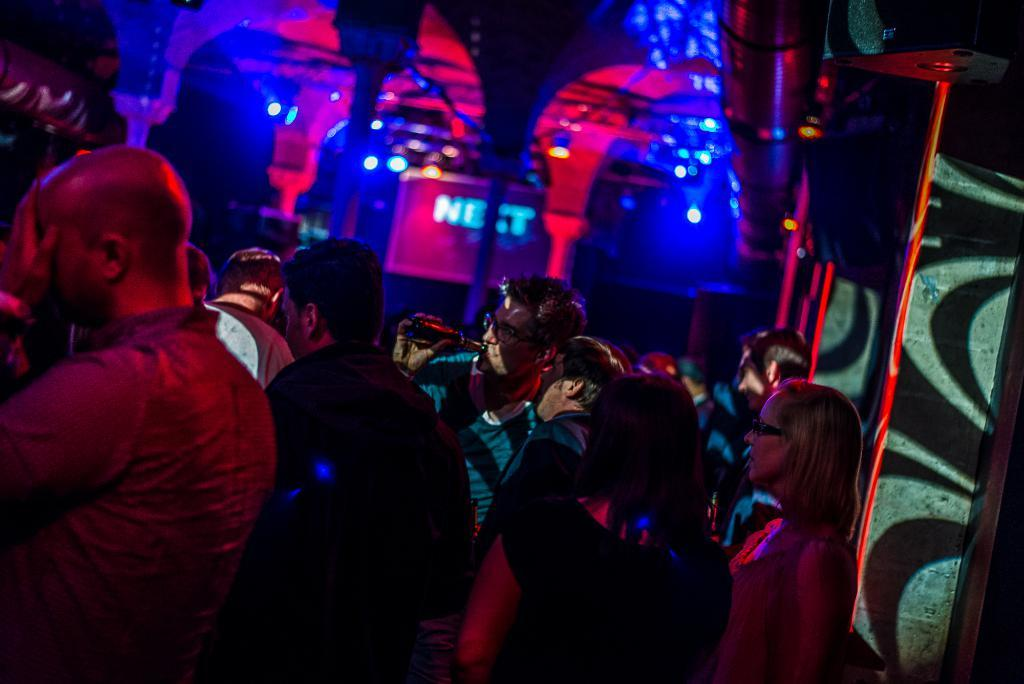What is the main focus of the image? The main focus of the image is the many people standing in the center. What can be seen in the background of the image? There are pillars visible in the background of the image. What is providing illumination in the image? There are lights visible in the image. What might be used for displaying information or visuals in the image? There is a screen present in the image. How many ladybugs are crawling on the screen in the image? There are no ladybugs present in the image; the screen is the only item mentioned in the facts. 